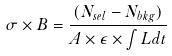<formula> <loc_0><loc_0><loc_500><loc_500>\sigma \times B = \frac { ( N _ { s e l } - N _ { b k g } ) } { A \times \epsilon \times \int L d t }</formula> 